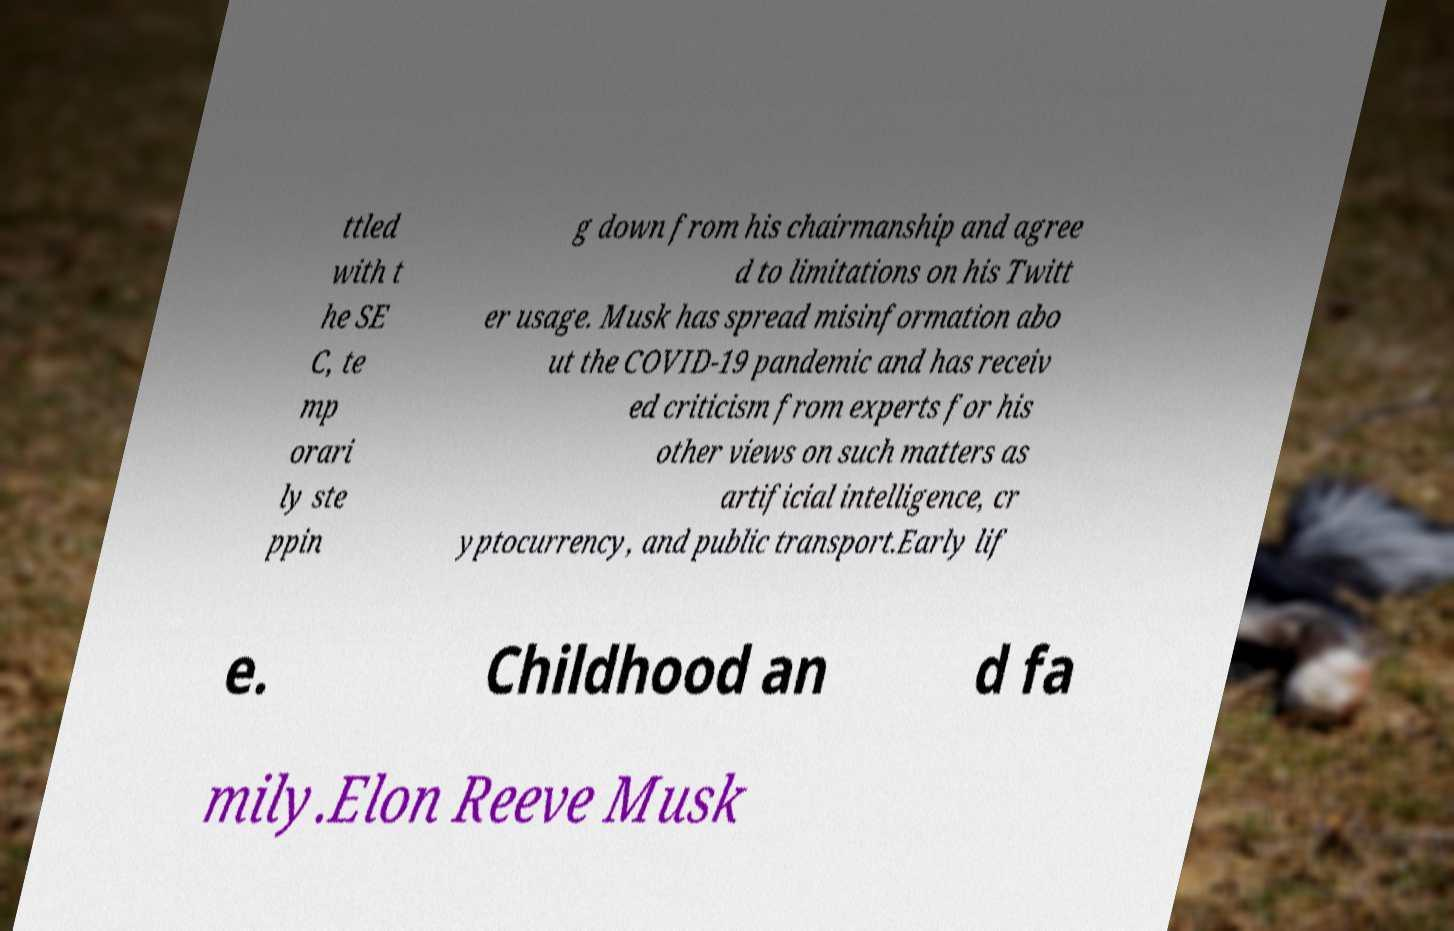Could you assist in decoding the text presented in this image and type it out clearly? ttled with t he SE C, te mp orari ly ste ppin g down from his chairmanship and agree d to limitations on his Twitt er usage. Musk has spread misinformation abo ut the COVID-19 pandemic and has receiv ed criticism from experts for his other views on such matters as artificial intelligence, cr yptocurrency, and public transport.Early lif e. Childhood an d fa mily.Elon Reeve Musk 